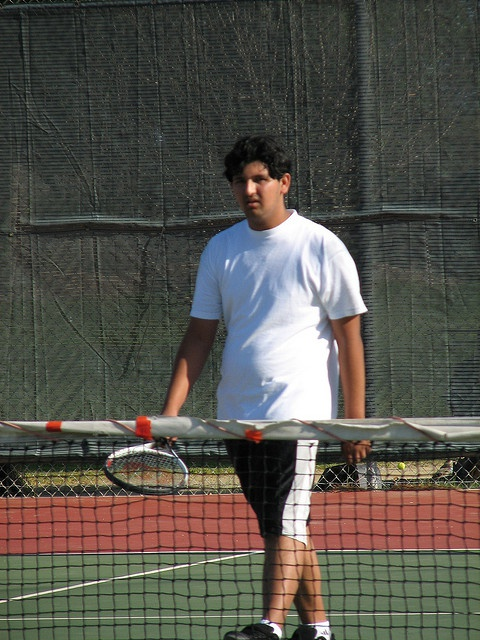Describe the objects in this image and their specific colors. I can see people in black, white, gray, and brown tones, tennis racket in black, gray, and ivory tones, and sports ball in black, olive, and khaki tones in this image. 